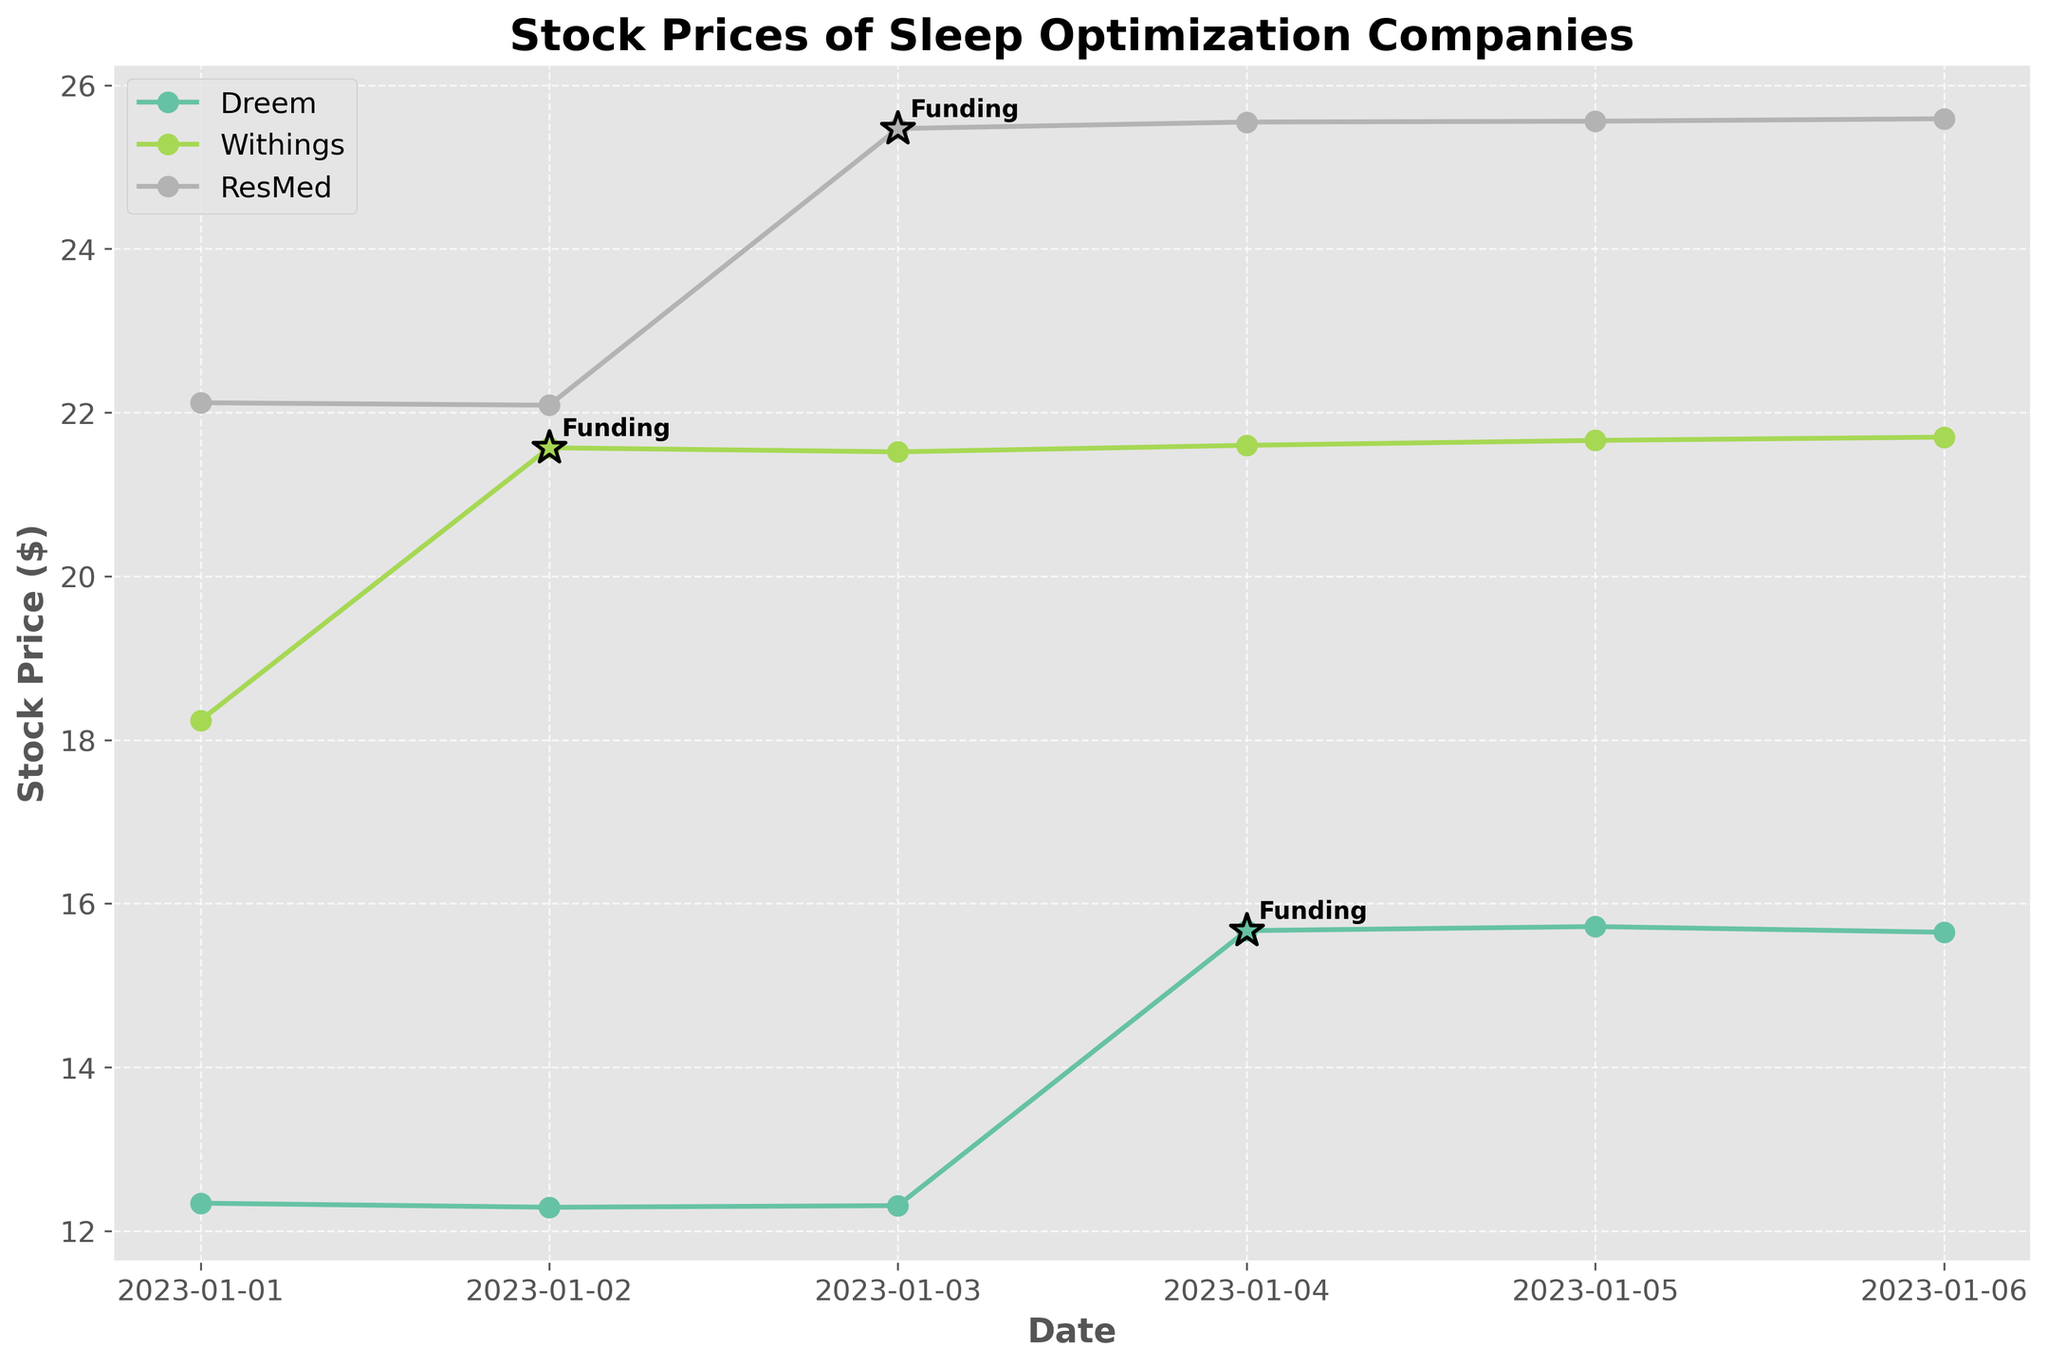What is the title of the plot? The title is usually positioned at the top of the figure and it summarizes the main focus of the plot. In this case, it states "Stock Prices of Sleep Optimization Companies."
Answer: Stock Prices of Sleep Optimization Companies Which company had the highest stock price on January 1, 2023? By looking at the data points on January 1, 2023, across all companies, Withings has the highest stock price at 18.24, compared to Dreem at 12.34 and ResMed at 22.12.
Answer: ResMed How does Dreem's stock price change after their funding announcement on January 4, 2023? Dreem's stock price increased from 12.31 on January 3 to 15.67 on January 4, marking a significant jump post-announcement. It continued to stay above the 15 mark in subsequent days.
Answer: The stock price increased significantly and remained higher Is there a noticeable trend in the stock prices of Withings after their funding announcement? Withings' stock price jumps from 18.24 on January 1 to 21.57 on January 2, the day of the funding announcement, and then remains on an upward trend, slowly increasing each day after. This indicates a positive trend post-announcement.
Answer: Yes, an upward trend Compare the impact of funding announcements on the stock prices of all three companies. Which company saw the highest increase in their stock price? Dreem's stock price increased from 12.31 to 15.67 (a rise of 3.36), Withings from 18.24 to 21.57 (a rise of 3.33), and ResMed from 22.09 to 25.47 (a rise of 3.38). By calculating the differences, ResMed saw the highest absolute increase.
Answer: ResMed What was Withings' stock price the day before their funding announcement? Referring to the date just before January 2 (i.e., January 1), Withings' stock price was 18.24 as shown in the plot under the respective date.
Answer: 18.24 How does ResMed's stock price trajectory compare to Dreem's over the entire period shown? Both companies' stock prices increased notably after their respective funding announcements. Dreem showed a significant rise on January 4, while ResMed had a similar notable jump on January 3. However, ResMed consistently maintained a higher stock price throughout the period compared to Dreem.
Answer: ResMed maintained a higher stock price throughout What is the average stock price of Withings from January 1 to January 6, 2023? To find the average, sum Withings' stock prices (18.24, 21.57, 21.52, 21.60, 21.66, 21.70) and divide by the number of days (6). The total is 126.29, and the average is 126.29/6.
Answer: 21.05 How did Dreem's stock price on January 3 compare to its price on January 5? Dreem's stock price on January 3 was 12.31 and on January 5 it was 15.72. By calculating the difference, we find that Dreem's stock price increased by 3.41 points.
Answer: Increased by 3.41 points Which company had the smallest change in stock price over the entire period, and what was that change? To find this, calculate the difference between the first and last stock price for each company: Dreem (12.34 to 15.65 = 3.31), Withings (18.24 to 21.70 = 3.46), ResMed (22.12 to 25.59 = 3.47). Dreem had the smallest change at 3.31.
Answer: Dreem with a change of 3.31 